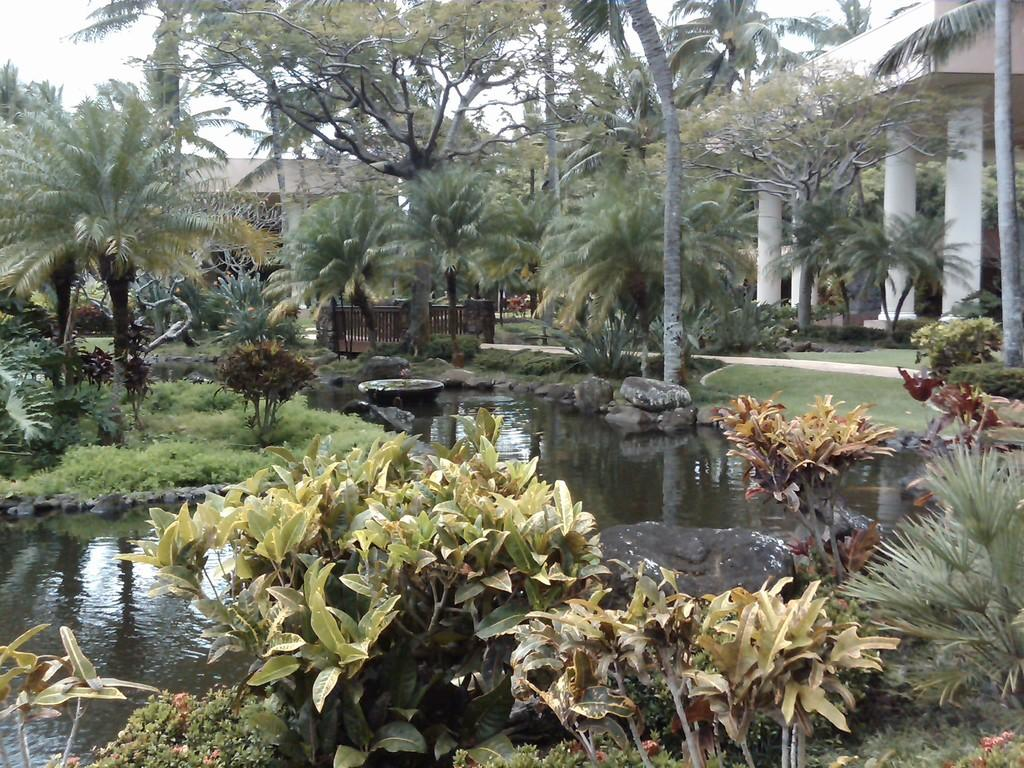What type of natural elements can be seen in the image? There are plants and trees in the image. What body of water is visible in the image? There is a lake in the image. What type of structures can be seen in the background of the image? There are buildings in the background of the image. What type of guitar can be seen hanging from the tree in the image? There is no guitar present in the image; it features plants, trees, a lake, and buildings. 